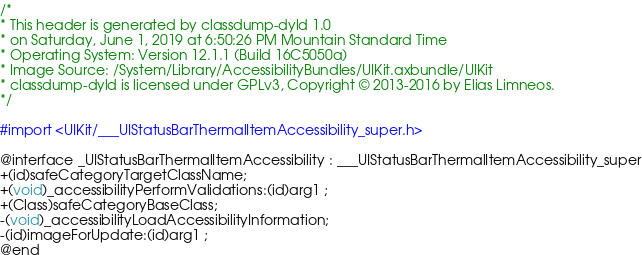Convert code to text. <code><loc_0><loc_0><loc_500><loc_500><_C_>/*
* This header is generated by classdump-dyld 1.0
* on Saturday, June 1, 2019 at 6:50:26 PM Mountain Standard Time
* Operating System: Version 12.1.1 (Build 16C5050a)
* Image Source: /System/Library/AccessibilityBundles/UIKit.axbundle/UIKit
* classdump-dyld is licensed under GPLv3, Copyright © 2013-2016 by Elias Limneos.
*/

#import <UIKit/___UIStatusBarThermalItemAccessibility_super.h>

@interface _UIStatusBarThermalItemAccessibility : ___UIStatusBarThermalItemAccessibility_super
+(id)safeCategoryTargetClassName;
+(void)_accessibilityPerformValidations:(id)arg1 ;
+(Class)safeCategoryBaseClass;
-(void)_accessibilityLoadAccessibilityInformation;
-(id)imageForUpdate:(id)arg1 ;
@end

</code> 